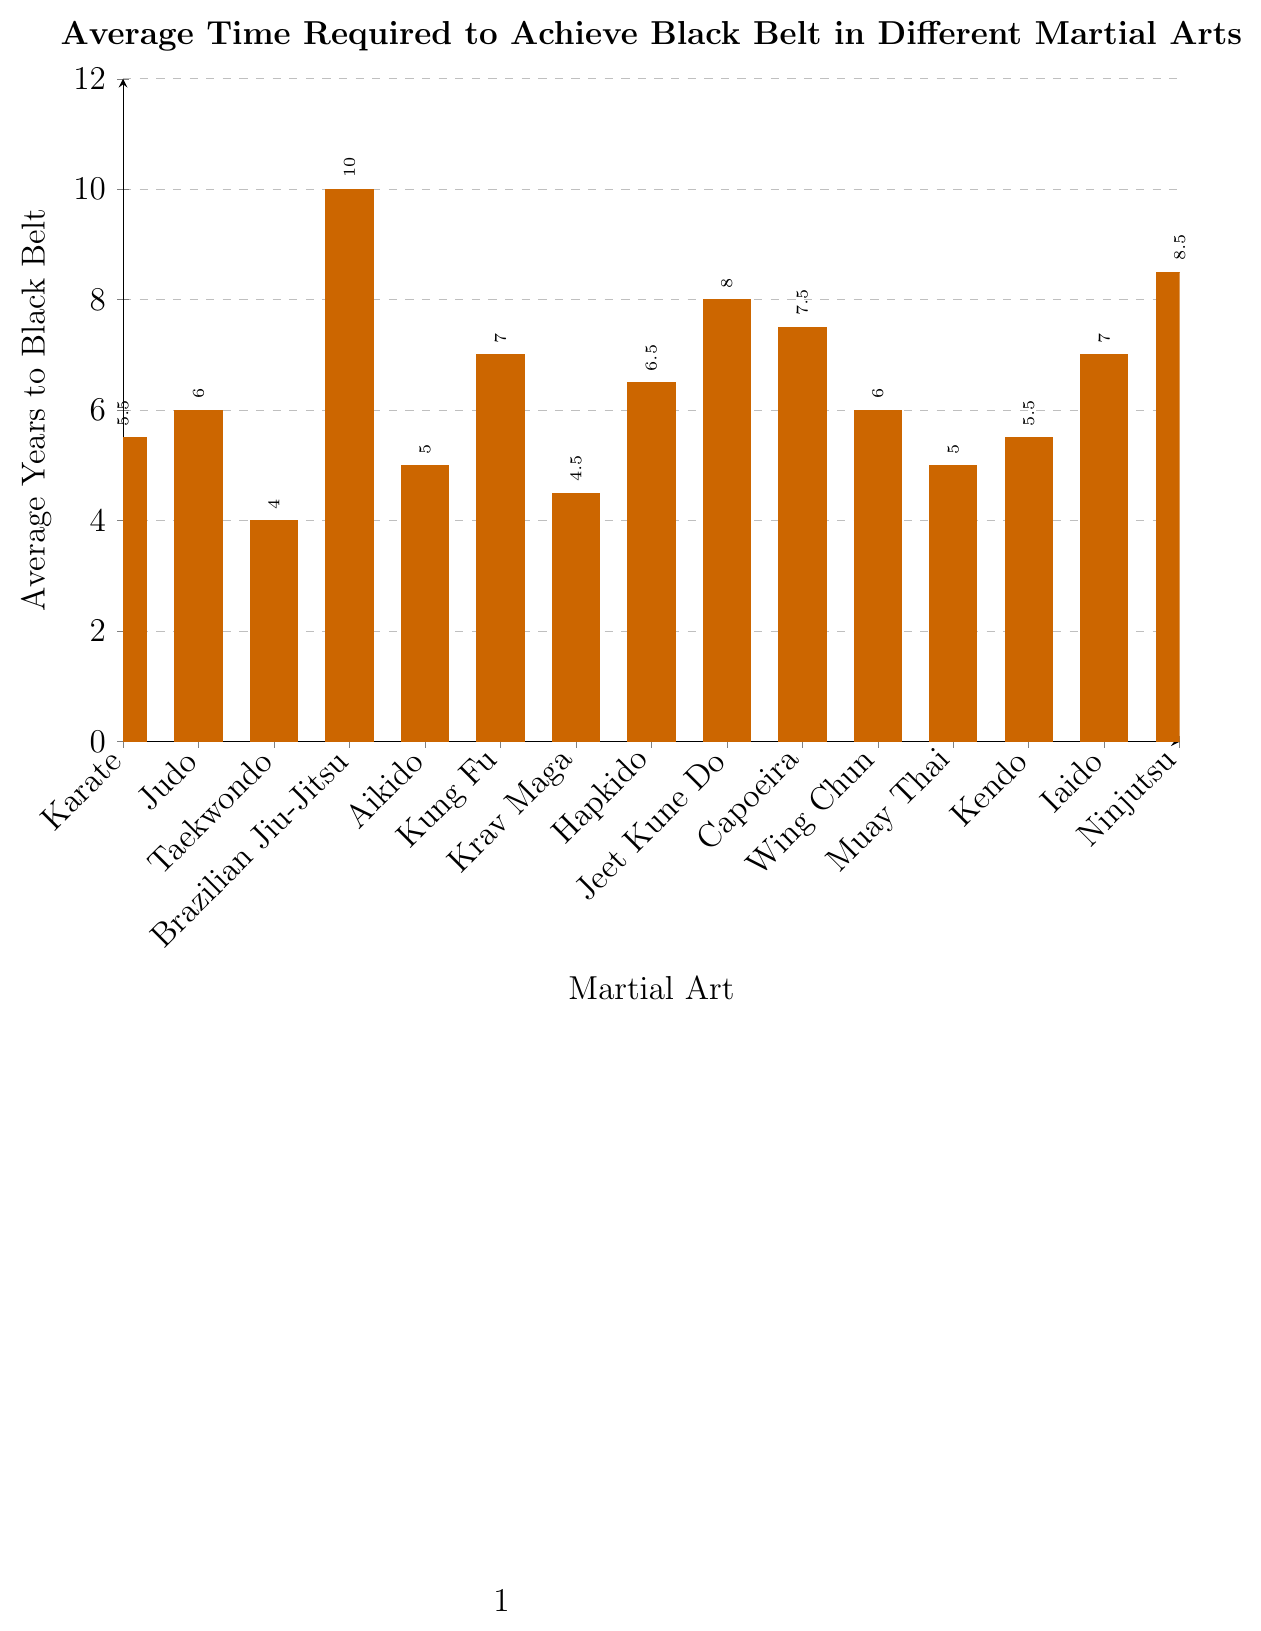What martial arts discipline requires the least time to achieve a black belt? By looking at the bar lengths, we see that Taekwondo has the shortest bar, indicating the shortest time to achieve a black belt.
Answer: Taekwondo Which martial arts discipline requires the most time to achieve a black belt? By observing the longest bar in the chart, it corresponds to Brazilian Jiu-Jitsu.
Answer: Brazilian Jiu-Jitsu What is the total combined time to achieve black belts in Karate, Judo, and Taekwondo? Sum the average years for Karate (5.5), Judo (6), and Taekwondo (4): 5.5 + 6 + 4 = 15.5.
Answer: 15.5 How much longer does it take on average to achieve a black belt in Brazilian Jiu-Jitsu compared to Taekwondo? Brazilian Jiu-Jitsu takes 10 years and Taekwondo takes 4 years, so the difference is 10 - 4 = 6 years.
Answer: 6 years Which disciplines have an average time to black belt equal to or greater than 7 years? Observing the chart, the disciplines are Kung Fu, Jeet Kune Do, Capoeira, Iaido, and Ninjutsu.
Answer: Kung Fu, Jeet Kune Do, Capoeira, Iaido, Ninjutsu Compare the time required to achieve a black belt in Hapkido and Capoeira. Which one takes longer and by how much? Hapkido takes an average of 6.5 years, while Capoeira takes 7.5 years. The difference is 7.5 - 6.5 = 1 year. Capoeira takes longer.
Answer: Capoeira, 1 year What is the average time required to achieve a black belt across all martial arts listed? The total combined time is 108.5 years for 15 disciplines: 108.5 / 15 = 7.23.
Answer: 7.23 years Which martial arts require less than 5 years on average to achieve a black belt? By looking at the chart, Taekwondo (4 years) and Krav Maga (4.5 years) are the disciplines that fit this criterion.
Answer: Taekwondo, Krav Maga What is the difference in time to achieve a black belt between Ninjutsu and Krav Maga? Ninjutsu takes 8.5 years and Krav Maga takes 4.5 years. The difference is 8.5 - 4.5 = 4 years.
Answer: 4 years 